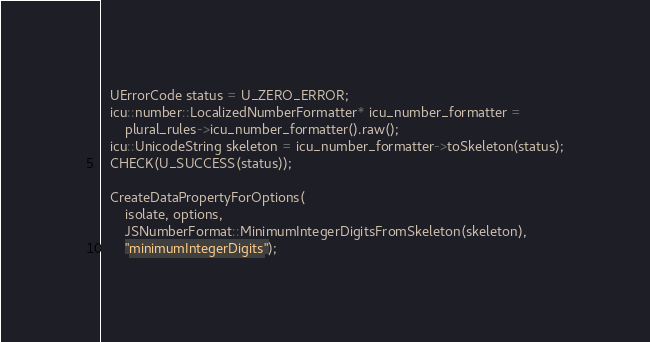Convert code to text. <code><loc_0><loc_0><loc_500><loc_500><_C++_>  UErrorCode status = U_ZERO_ERROR;
  icu::number::LocalizedNumberFormatter* icu_number_formatter =
      plural_rules->icu_number_formatter().raw();
  icu::UnicodeString skeleton = icu_number_formatter->toSkeleton(status);
  CHECK(U_SUCCESS(status));

  CreateDataPropertyForOptions(
      isolate, options,
      JSNumberFormat::MinimumIntegerDigitsFromSkeleton(skeleton),
      "minimumIntegerDigits");</code> 